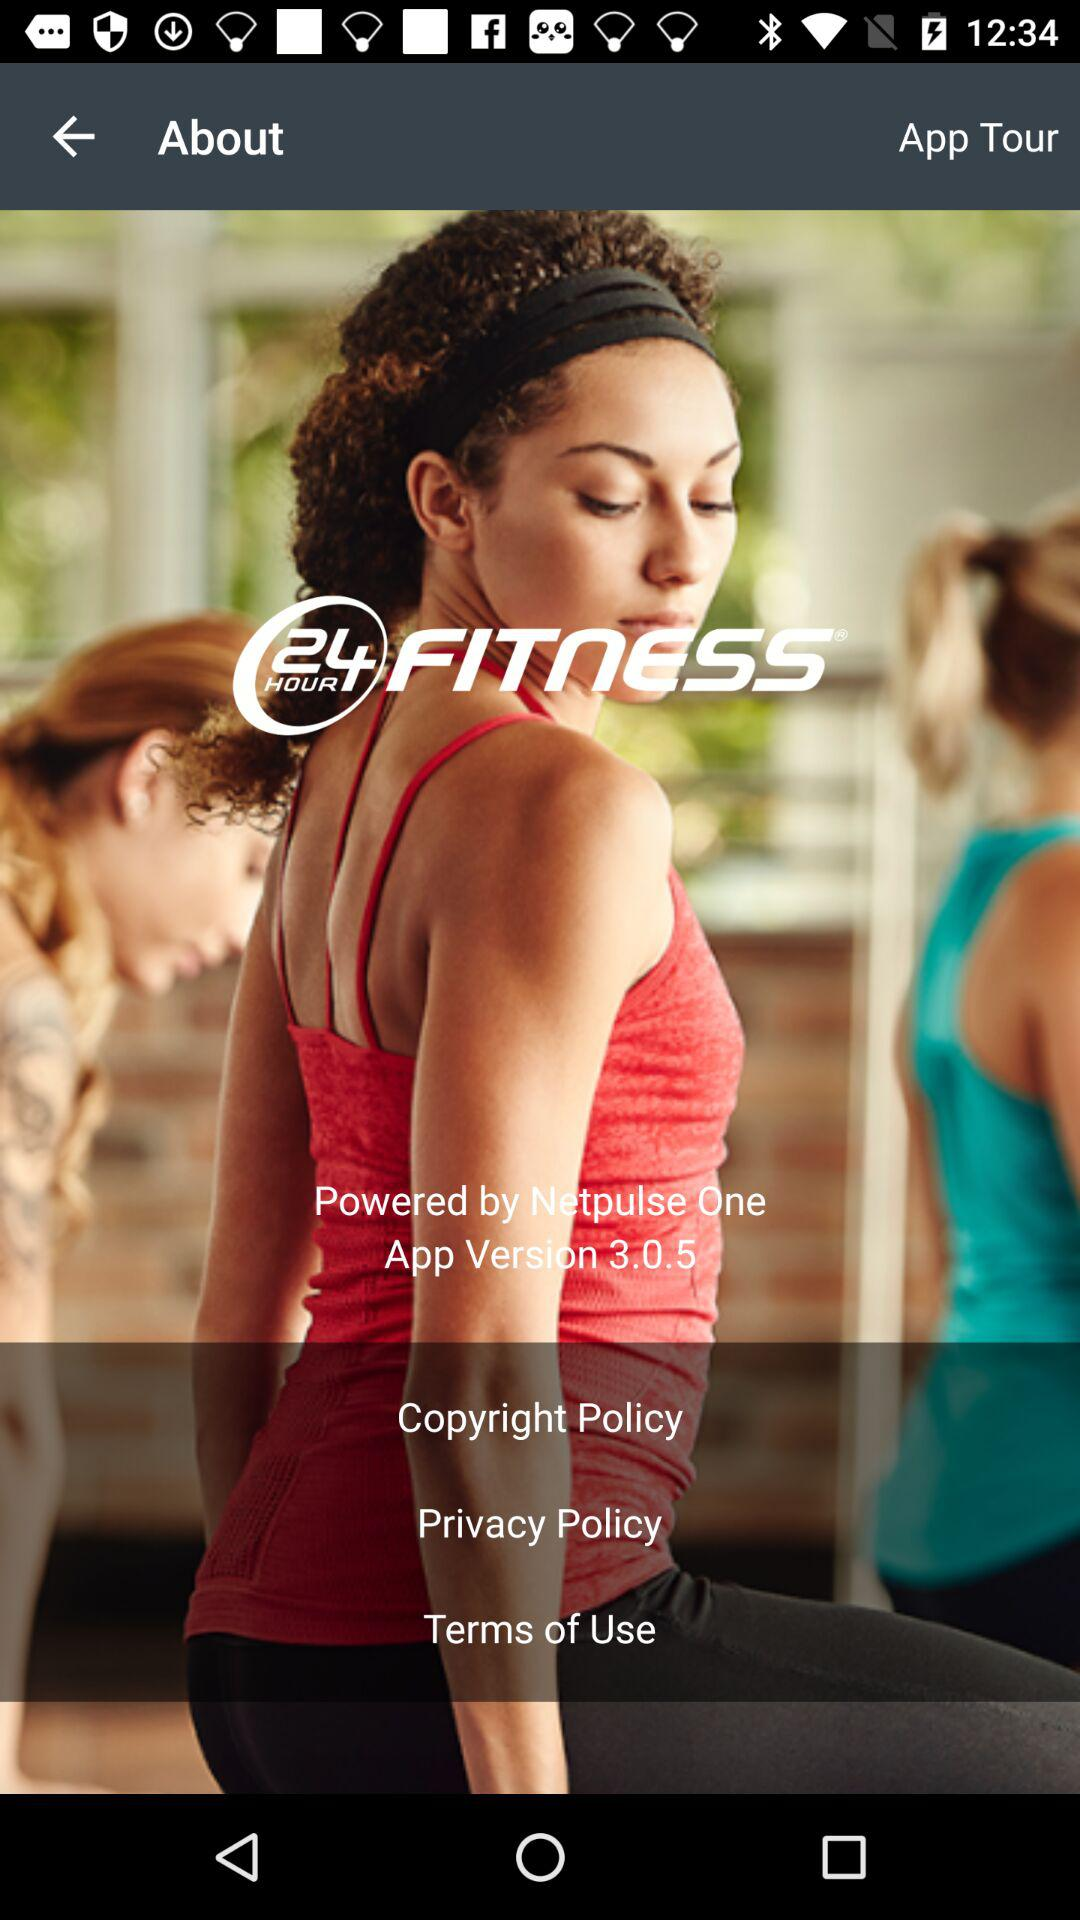What is the name of the application? The name of the application is "24 HOUR FITNESS". 